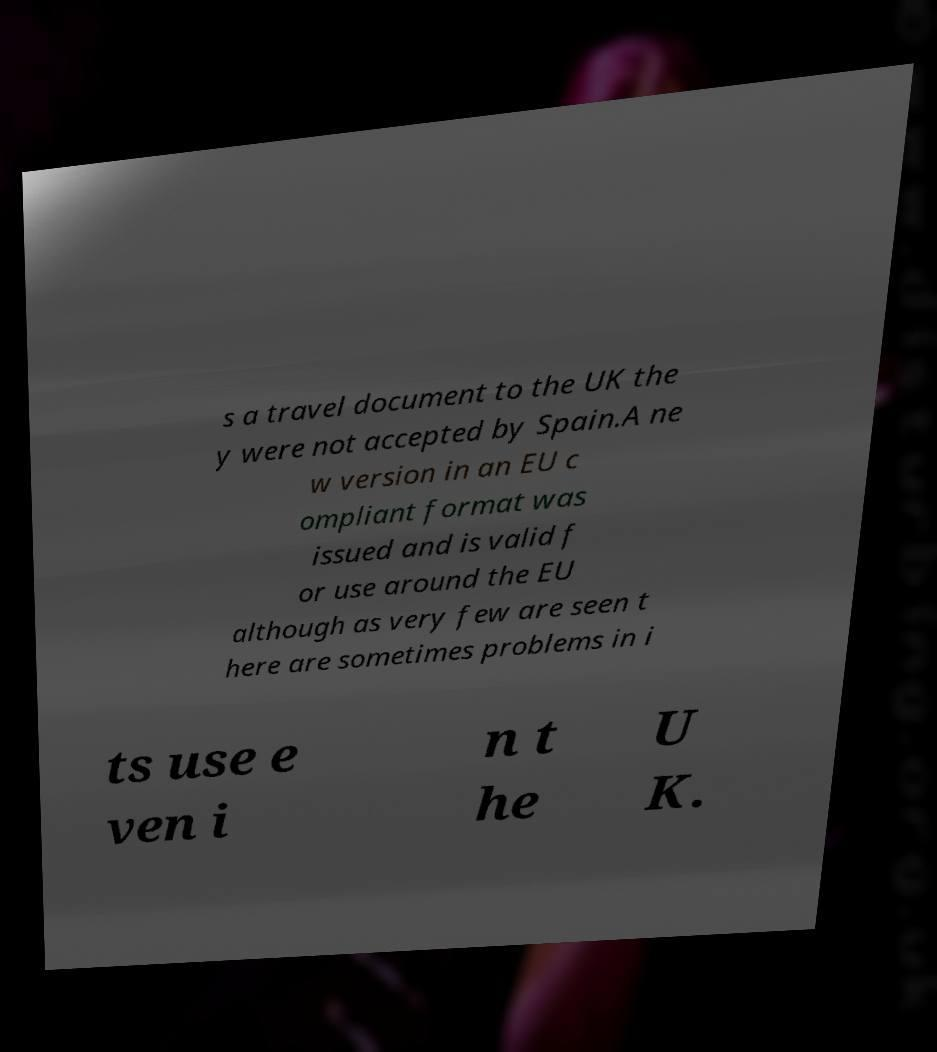Please identify and transcribe the text found in this image. s a travel document to the UK the y were not accepted by Spain.A ne w version in an EU c ompliant format was issued and is valid f or use around the EU although as very few are seen t here are sometimes problems in i ts use e ven i n t he U K. 